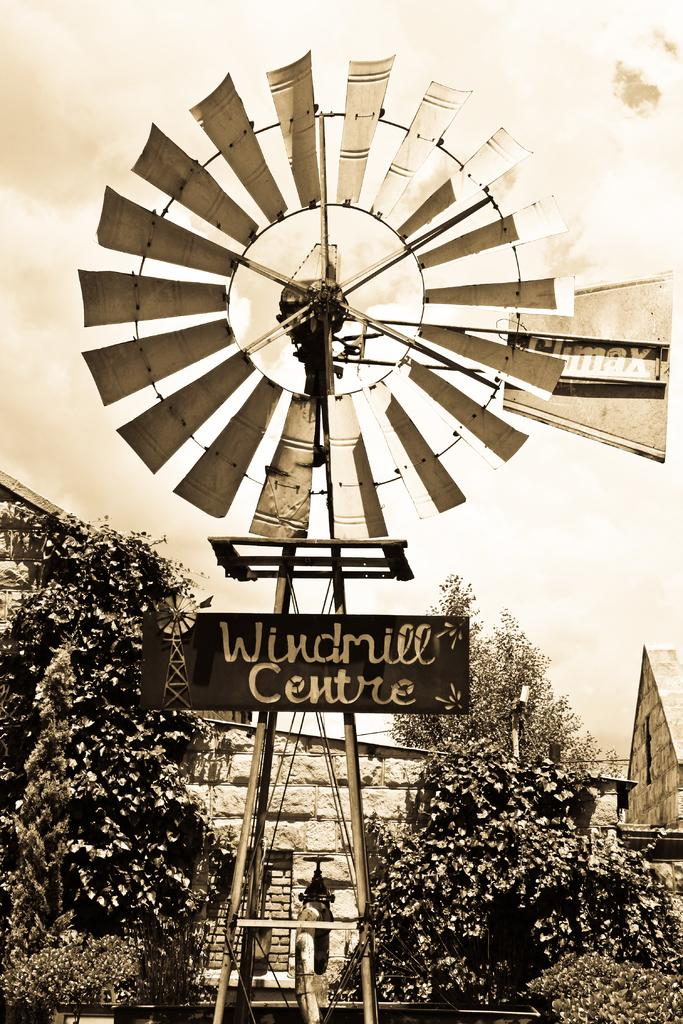What is the main structure in the image? There is a windmill in the image. What is written on the windmill? The windmill has "windmill center" written on it. What can be seen in the background of the image? There are trees and houses in the background of the image. What is the condition of the sky in the image? The sky is clear and visible in the background of the image. What type of pear is hanging from the branch in the image? There is no pear or branch present in the image; it features a windmill with "windmill center" written on it, surrounded by trees and houses. How is the coal being used in the image? There is no coal present in the image. 